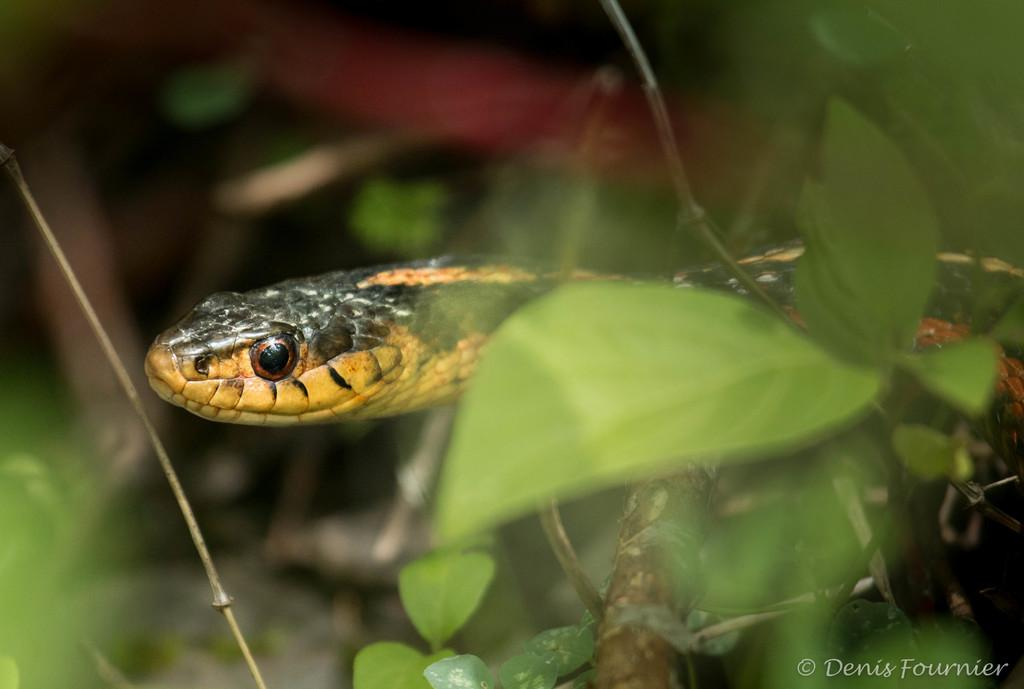What animal can be seen in the image? There is a snake in the image. What type of vegetation is visible in the foreground of the image? There are leaves and a stem in the foreground of the image. How would you describe the background of the image? The background of the image is blurry. Is there any text present in the image? Yes, there is text in the bottom right corner of the image. What advice does the manager give to the snake in the image? There is no manager present in the image, and therefore no advice can be given. 